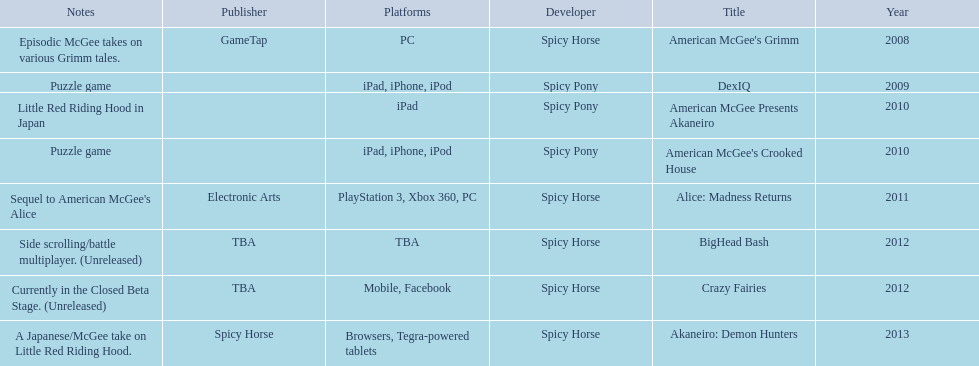What are all the titles? American McGee's Grimm, DexIQ, American McGee Presents Akaneiro, American McGee's Crooked House, Alice: Madness Returns, BigHead Bash, Crazy Fairies, Akaneiro: Demon Hunters. What platforms were they available on? PC, iPad, iPhone, iPod, iPad, iPad, iPhone, iPod, PlayStation 3, Xbox 360, PC, TBA, Mobile, Facebook, Browsers, Tegra-powered tablets. And which were available only on the ipad? American McGee Presents Akaneiro. 